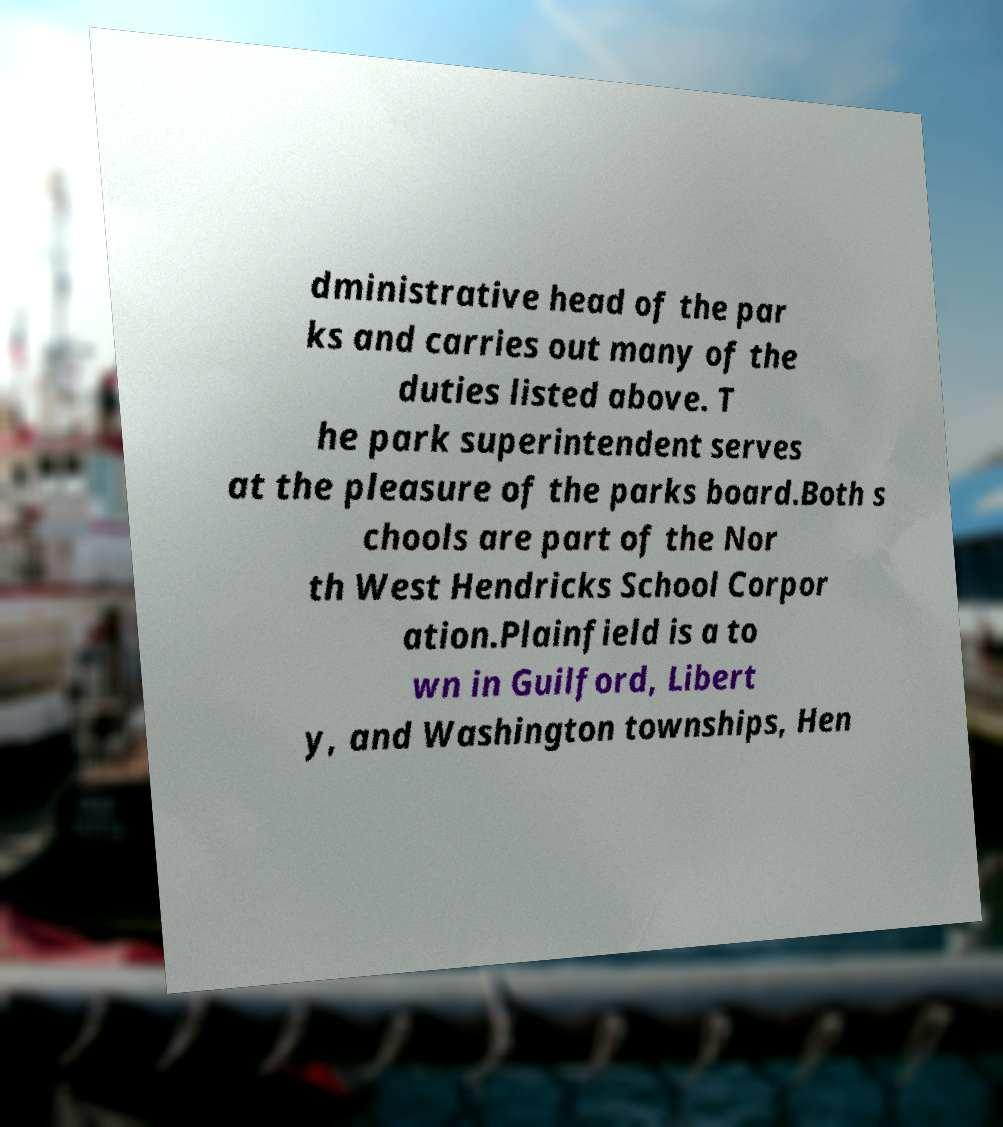Can you accurately transcribe the text from the provided image for me? dministrative head of the par ks and carries out many of the duties listed above. T he park superintendent serves at the pleasure of the parks board.Both s chools are part of the Nor th West Hendricks School Corpor ation.Plainfield is a to wn in Guilford, Libert y, and Washington townships, Hen 